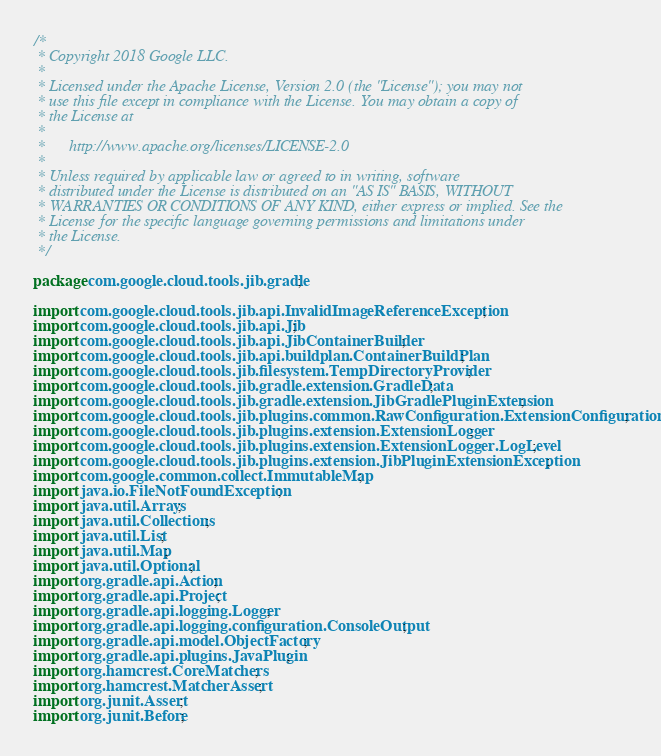<code> <loc_0><loc_0><loc_500><loc_500><_Java_>/*
 * Copyright 2018 Google LLC.
 *
 * Licensed under the Apache License, Version 2.0 (the "License"); you may not
 * use this file except in compliance with the License. You may obtain a copy of
 * the License at
 *
 *      http://www.apache.org/licenses/LICENSE-2.0
 *
 * Unless required by applicable law or agreed to in writing, software
 * distributed under the License is distributed on an "AS IS" BASIS, WITHOUT
 * WARRANTIES OR CONDITIONS OF ANY KIND, either express or implied. See the
 * License for the specific language governing permissions and limitations under
 * the License.
 */

package com.google.cloud.tools.jib.gradle;

import com.google.cloud.tools.jib.api.InvalidImageReferenceException;
import com.google.cloud.tools.jib.api.Jib;
import com.google.cloud.tools.jib.api.JibContainerBuilder;
import com.google.cloud.tools.jib.api.buildplan.ContainerBuildPlan;
import com.google.cloud.tools.jib.filesystem.TempDirectoryProvider;
import com.google.cloud.tools.jib.gradle.extension.GradleData;
import com.google.cloud.tools.jib.gradle.extension.JibGradlePluginExtension;
import com.google.cloud.tools.jib.plugins.common.RawConfiguration.ExtensionConfiguration;
import com.google.cloud.tools.jib.plugins.extension.ExtensionLogger;
import com.google.cloud.tools.jib.plugins.extension.ExtensionLogger.LogLevel;
import com.google.cloud.tools.jib.plugins.extension.JibPluginExtensionException;
import com.google.common.collect.ImmutableMap;
import java.io.FileNotFoundException;
import java.util.Arrays;
import java.util.Collections;
import java.util.List;
import java.util.Map;
import java.util.Optional;
import org.gradle.api.Action;
import org.gradle.api.Project;
import org.gradle.api.logging.Logger;
import org.gradle.api.logging.configuration.ConsoleOutput;
import org.gradle.api.model.ObjectFactory;
import org.gradle.api.plugins.JavaPlugin;
import org.hamcrest.CoreMatchers;
import org.hamcrest.MatcherAssert;
import org.junit.Assert;
import org.junit.Before;</code> 